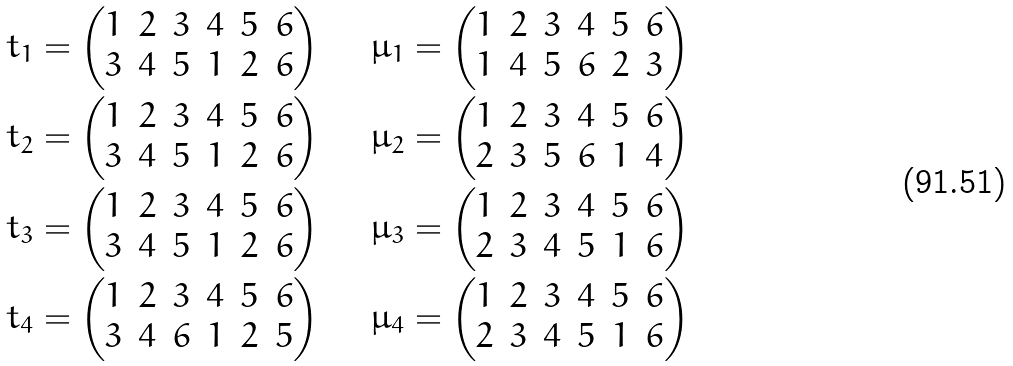Convert formula to latex. <formula><loc_0><loc_0><loc_500><loc_500>\ t _ { 1 } & = \begin{pmatrix} 1 & 2 & 3 & 4 & 5 & 6 \\ 3 & 4 & 5 & 1 & 2 & 6 \end{pmatrix} \ \quad \mu _ { 1 } = \begin{pmatrix} 1 & 2 & 3 & 4 & 5 & 6 \\ 1 & 4 & 5 & 6 & 2 & 3 \end{pmatrix} \\ \ t _ { 2 } & = \begin{pmatrix} 1 & 2 & 3 & 4 & 5 & 6 \\ 3 & 4 & 5 & 1 & 2 & 6 \end{pmatrix} \ \quad \mu _ { 2 } = \begin{pmatrix} 1 & 2 & 3 & 4 & 5 & 6 \\ 2 & 3 & 5 & 6 & 1 & 4 \end{pmatrix} \\ \ t _ { 3 } & = \begin{pmatrix} 1 & 2 & 3 & 4 & 5 & 6 \\ 3 & 4 & 5 & 1 & 2 & 6 \end{pmatrix} \ \quad \mu _ { 3 } = \begin{pmatrix} 1 & 2 & 3 & 4 & 5 & 6 \\ 2 & 3 & 4 & 5 & 1 & 6 \end{pmatrix} \\ \ t _ { 4 } & = \begin{pmatrix} 1 & 2 & 3 & 4 & 5 & 6 \\ 3 & 4 & 6 & 1 & 2 & 5 \end{pmatrix} \ \quad \mu _ { 4 } = \begin{pmatrix} 1 & 2 & 3 & 4 & 5 & 6 \\ 2 & 3 & 4 & 5 & 1 & 6 \end{pmatrix}</formula> 